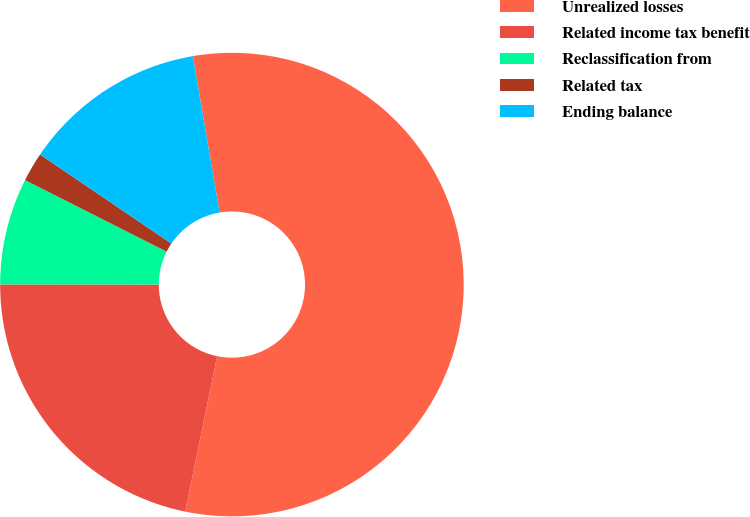Convert chart to OTSL. <chart><loc_0><loc_0><loc_500><loc_500><pie_chart><fcel>Unrealized losses<fcel>Related income tax benefit<fcel>Reclassification from<fcel>Related tax<fcel>Ending balance<nl><fcel>55.93%<fcel>21.78%<fcel>7.43%<fcel>2.04%<fcel>12.82%<nl></chart> 